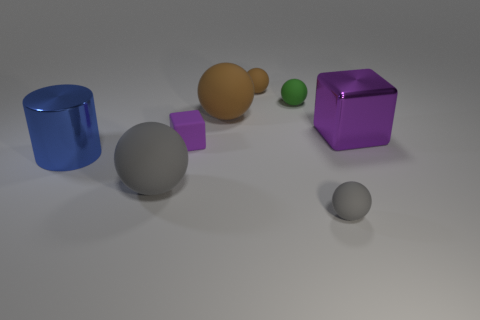What is the material of the object that is the same color as the large metallic block?
Your response must be concise. Rubber. Is the number of gray matte balls that are behind the tiny gray matte ball greater than the number of gray matte things that are behind the tiny cube?
Your answer should be compact. Yes. There is a cube left of the tiny gray object; does it have the same color as the large cube?
Provide a short and direct response. Yes. What is the size of the green object?
Your response must be concise. Small. There is a purple thing that is the same size as the cylinder; what material is it?
Keep it short and to the point. Metal. What is the color of the large rubber thing that is behind the blue metal thing?
Offer a very short reply. Brown. What number of yellow metallic blocks are there?
Ensure brevity in your answer.  0. There is a brown ball that is in front of the brown matte ball right of the big brown rubber thing; are there any spheres to the left of it?
Provide a succinct answer. Yes. What is the shape of the purple rubber thing that is the same size as the green rubber sphere?
Provide a succinct answer. Cube. How many other objects are there of the same color as the large cube?
Your response must be concise. 1. 